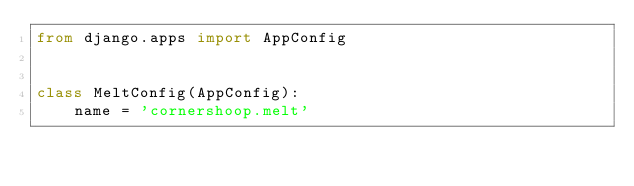<code> <loc_0><loc_0><loc_500><loc_500><_Python_>from django.apps import AppConfig


class MeltConfig(AppConfig):
    name = 'cornershoop.melt'
</code> 